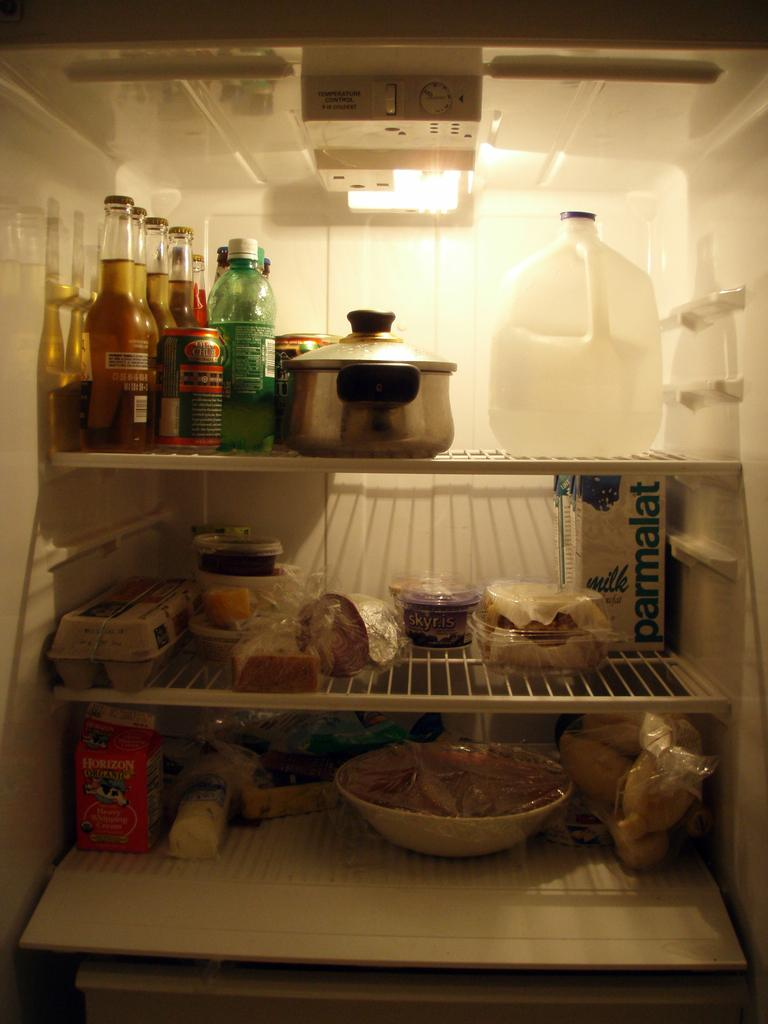<image>
Share a concise interpretation of the image provided. Parmalat Milk is shown on the carton in the middle, right side shelf of the fridge. 